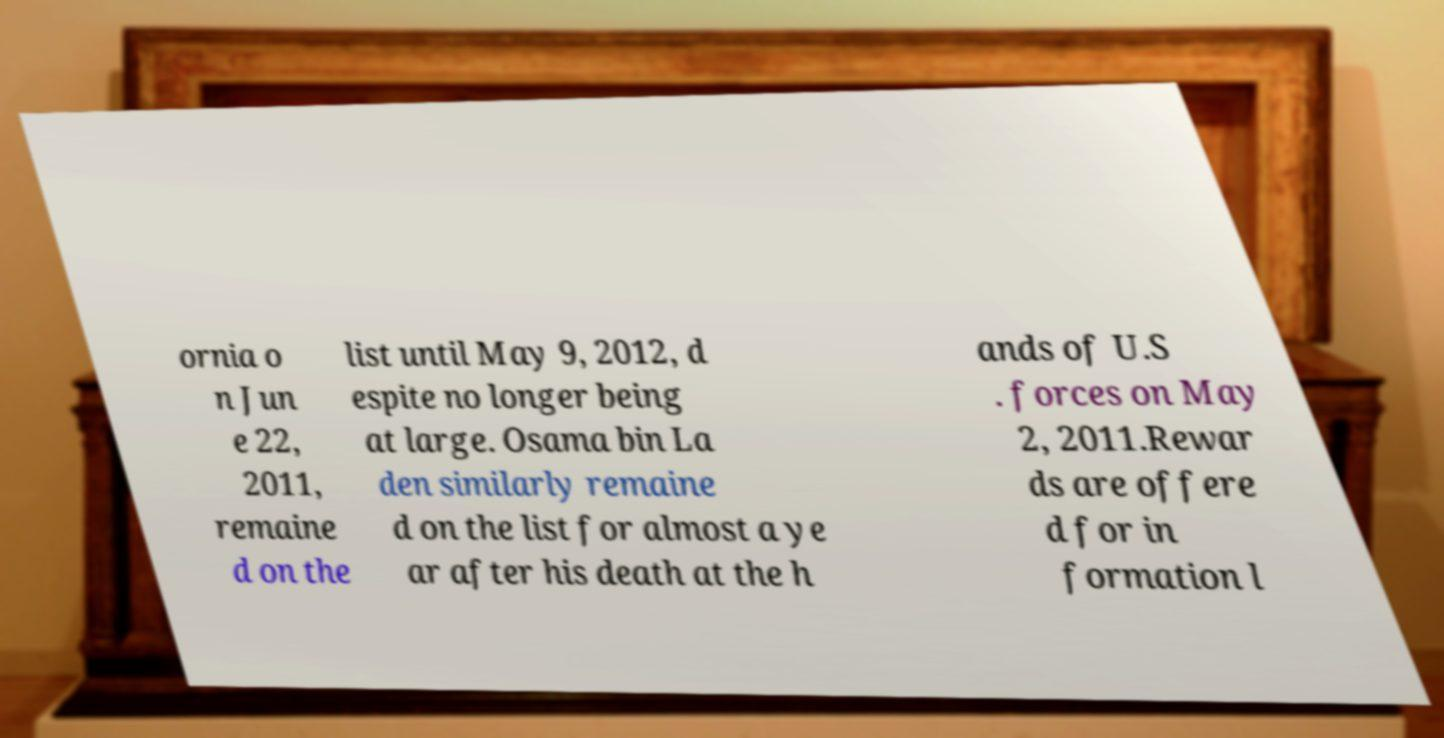Could you assist in decoding the text presented in this image and type it out clearly? ornia o n Jun e 22, 2011, remaine d on the list until May 9, 2012, d espite no longer being at large. Osama bin La den similarly remaine d on the list for almost a ye ar after his death at the h ands of U.S . forces on May 2, 2011.Rewar ds are offere d for in formation l 